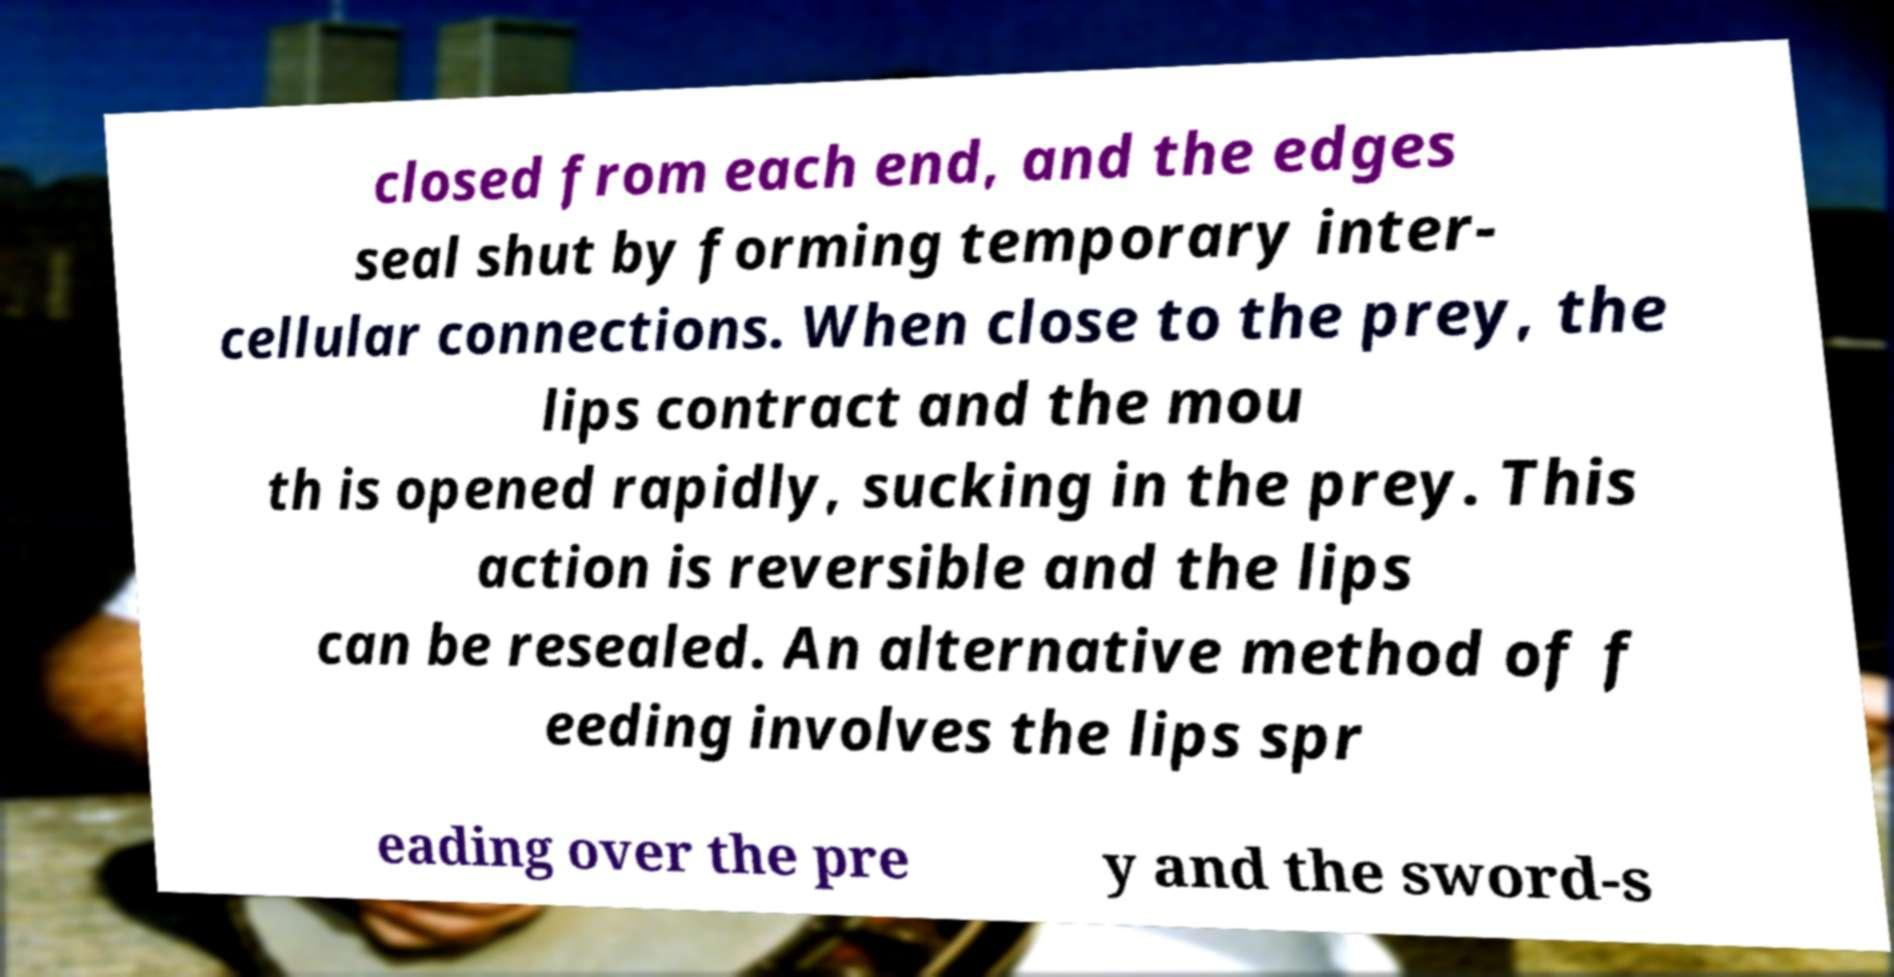For documentation purposes, I need the text within this image transcribed. Could you provide that? closed from each end, and the edges seal shut by forming temporary inter- cellular connections. When close to the prey, the lips contract and the mou th is opened rapidly, sucking in the prey. This action is reversible and the lips can be resealed. An alternative method of f eeding involves the lips spr eading over the pre y and the sword-s 